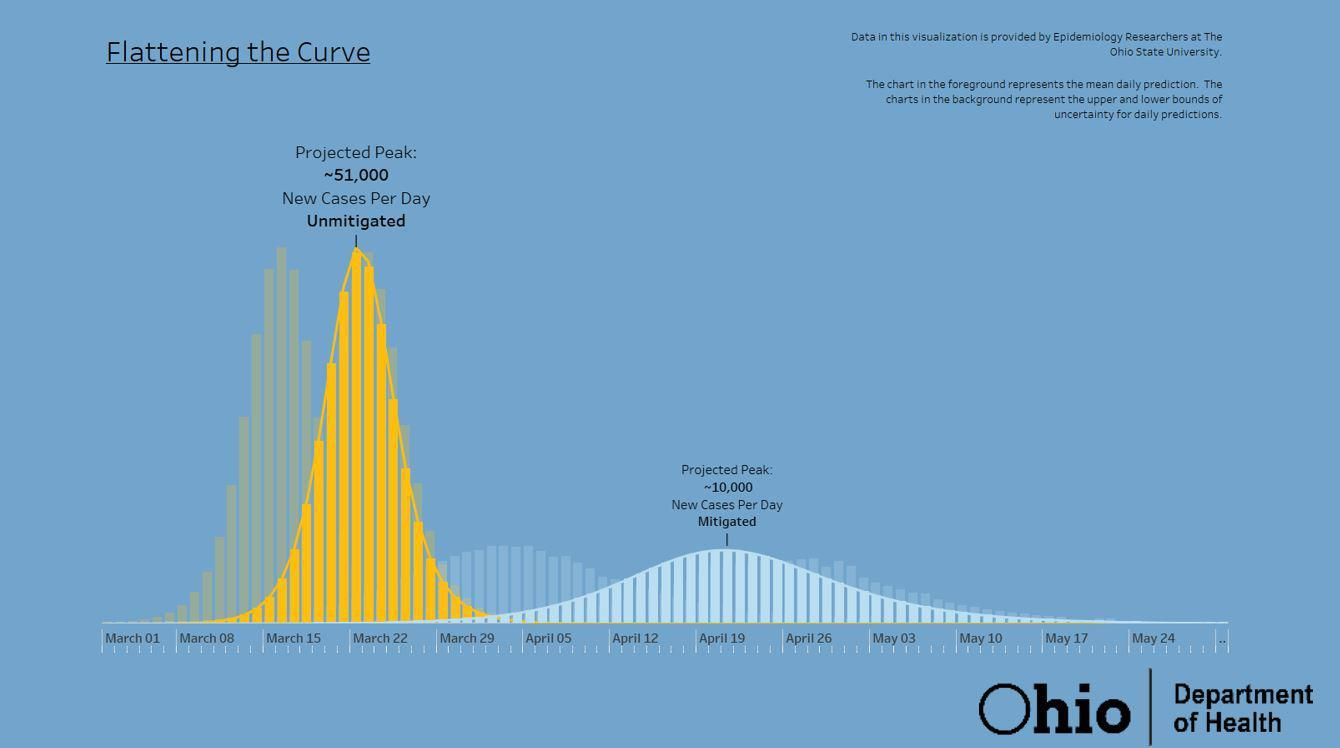Identify some key points in this picture. The two projected peaks differ by approximately 41,000. The graph contains three months. 